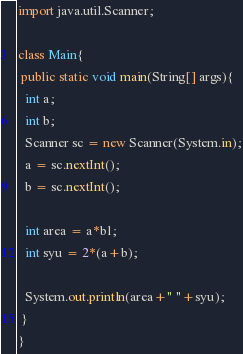Convert code to text. <code><loc_0><loc_0><loc_500><loc_500><_Java_>import java.util.Scanner;

class Main{
 public static void main(String[] args){
  int a;
  int b;
  Scanner sc = new Scanner(System.in);
  a = sc.nextInt();
  b = sc.nextInt();

  int area = a*bl;
  int syu = 2*(a+b);
  
  System.out.println(area+" "+syu);
 }
}</code> 